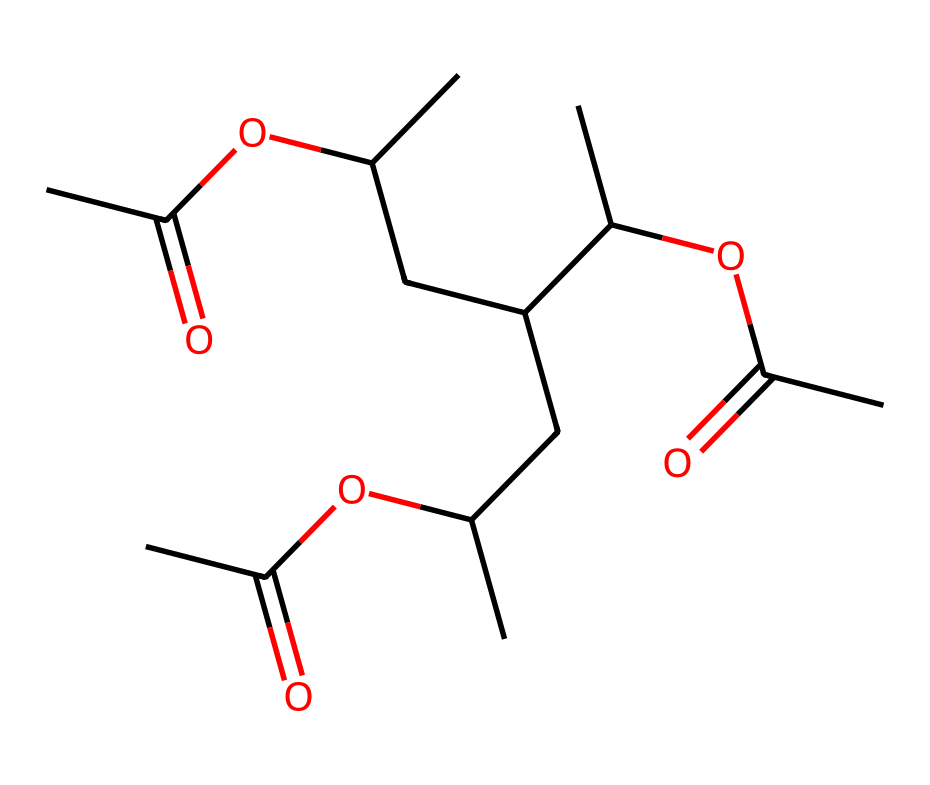What is the total number of carbon atoms in this polyvinyl acetate structure? By examining the SMILES representation, we can identify the number of carbon atoms. Each "C" in the SMILES signifies a carbon atom. Counting all the "C" elements yields a total of 15 carbon atoms.
Answer: 15 How many ester functional groups are present in this chemical? By analyzing the structure, the presence of "OC(=O)" indicates the presence of an ester functional group. Since there are three instances of "OC(=O)" in the SMILES, we conclude that there are three ester groups present in this molecule.
Answer: 3 What type of polymer is represented by this structure? The structure mainly consists of acetate linkages (indicated by the esters) and shows repetition in the backbone, characteristic of polyvinyl acetate, which is a type of vinyl polymer. Thus, this chemical represents a polymer type known as an addition polymer or vinyl polymer.
Answer: vinyl polymer Describe the type of bonding primarily present in polyvinyl acetate. In polyvinyl acetate, the carbon atoms are primarily connected through single covalent bonds. The ester functional groups also involve carbonyl C=O double bonds but generally, the backbone consists of single bonds. Thus, the primary bonding type is covalent bonding.
Answer: covalent How many oxygen atoms are in the structure? In the SMILES representation, the presence of "O" indicates oxygen atoms. By counting, there are a total of six oxygen atoms in the entire structure.
Answer: 6 What characteristic of polyvinyl acetate makes it suitable for paper conservation? Polyvinyl acetate, due to its adhesive properties and flexibility, is ideal for paper conservation. The presence of ester linkages contributes to its bonding capabilities, allowing it to effectively adhere and maintain the integrity of paper materials without causing damage.
Answer: adhesive properties 